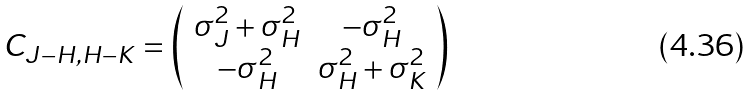Convert formula to latex. <formula><loc_0><loc_0><loc_500><loc_500>C _ { J - H , H - K } = \left ( \begin{array} { c c c } \sigma _ { J } ^ { 2 } + \sigma _ { H } ^ { 2 } & - \sigma _ { H } ^ { 2 } \\ - \sigma _ { H } ^ { 2 } & \sigma _ { H } ^ { 2 } + \sigma _ { K } ^ { 2 } \end{array} \right )</formula> 